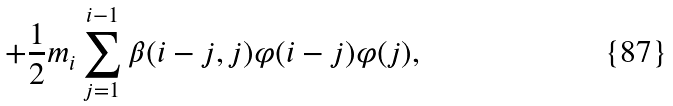Convert formula to latex. <formula><loc_0><loc_0><loc_500><loc_500>+ \frac { 1 } { 2 } m _ { i } \sum _ { j = 1 } ^ { i - 1 } \beta ( i - j , j ) \varphi ( i - j ) \varphi ( j ) ,</formula> 